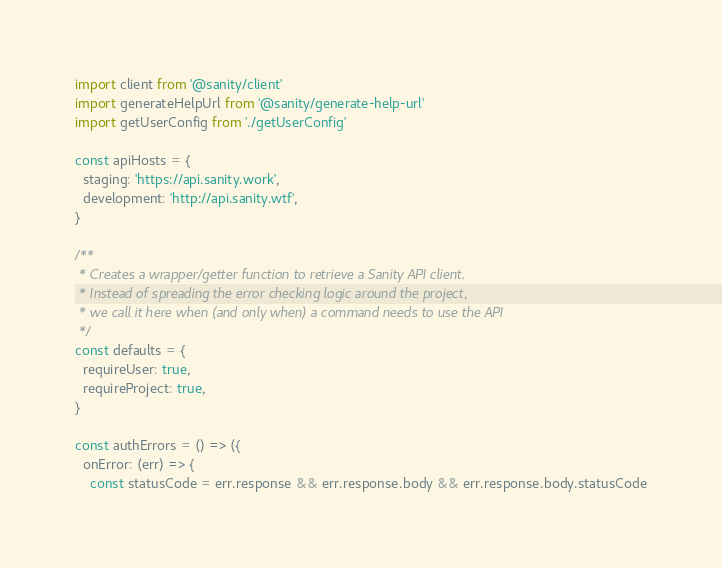<code> <loc_0><loc_0><loc_500><loc_500><_JavaScript_>import client from '@sanity/client'
import generateHelpUrl from '@sanity/generate-help-url'
import getUserConfig from './getUserConfig'

const apiHosts = {
  staging: 'https://api.sanity.work',
  development: 'http://api.sanity.wtf',
}

/**
 * Creates a wrapper/getter function to retrieve a Sanity API client.
 * Instead of spreading the error checking logic around the project,
 * we call it here when (and only when) a command needs to use the API
 */
const defaults = {
  requireUser: true,
  requireProject: true,
}

const authErrors = () => ({
  onError: (err) => {
    const statusCode = err.response && err.response.body && err.response.body.statusCode</code> 